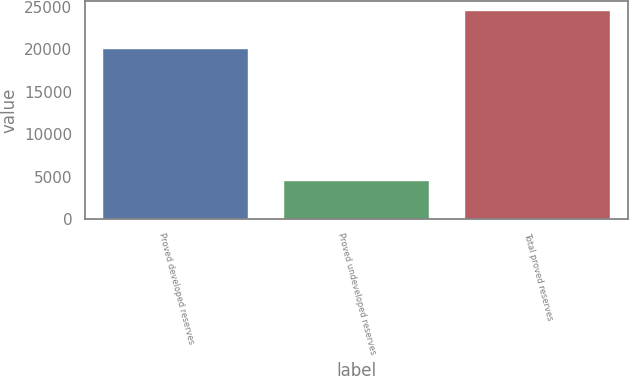<chart> <loc_0><loc_0><loc_500><loc_500><bar_chart><fcel>Proved developed reserves<fcel>Proved undeveloped reserves<fcel>Total proved reserves<nl><fcel>19982<fcel>4494<fcel>24476<nl></chart> 